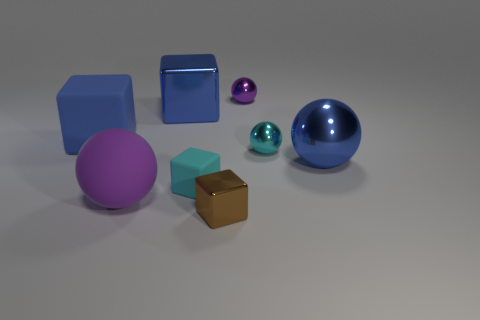Subtract all gray cubes. Subtract all yellow cylinders. How many cubes are left? 4 Add 1 blue spheres. How many objects exist? 9 Add 3 cyan shiny objects. How many cyan shiny objects are left? 4 Add 2 large metal balls. How many large metal balls exist? 3 Subtract 0 gray cubes. How many objects are left? 8 Subtract all blue shiny blocks. Subtract all large matte spheres. How many objects are left? 6 